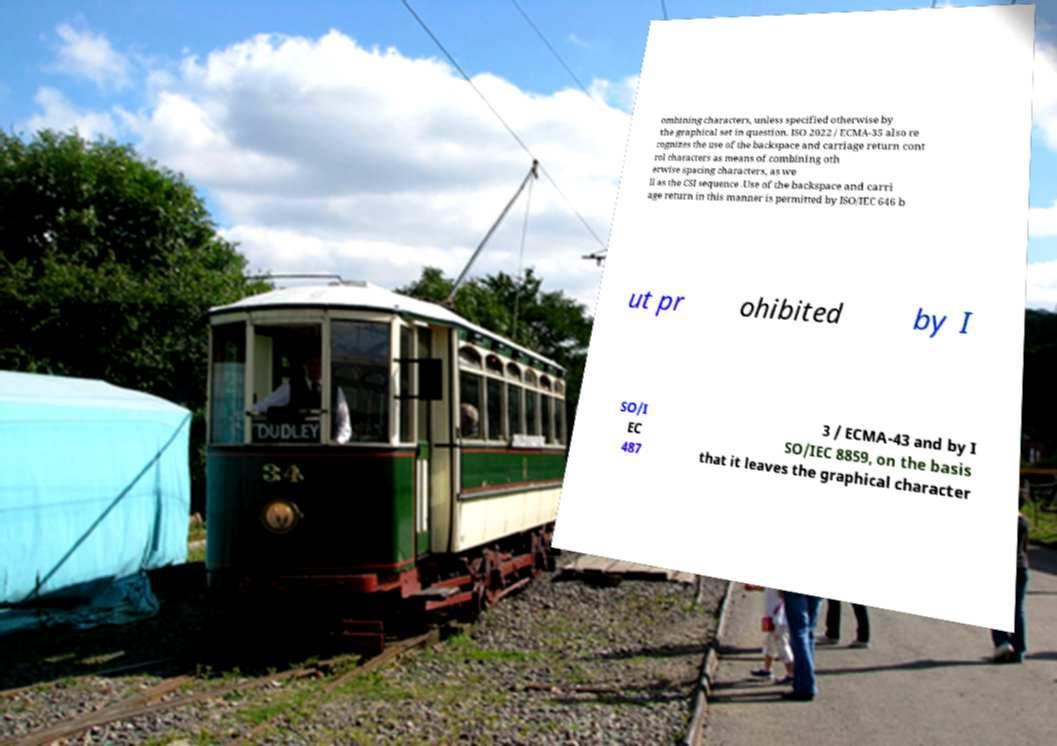What messages or text are displayed in this image? I need them in a readable, typed format. ombining characters, unless specified otherwise by the graphical set in question. ISO 2022 / ECMA-35 also re cognizes the use of the backspace and carriage return cont rol characters as means of combining oth erwise spacing characters, as we ll as the CSI sequence .Use of the backspace and carri age return in this manner is permitted by ISO/IEC 646 b ut pr ohibited by I SO/I EC 487 3 / ECMA-43 and by I SO/IEC 8859, on the basis that it leaves the graphical character 